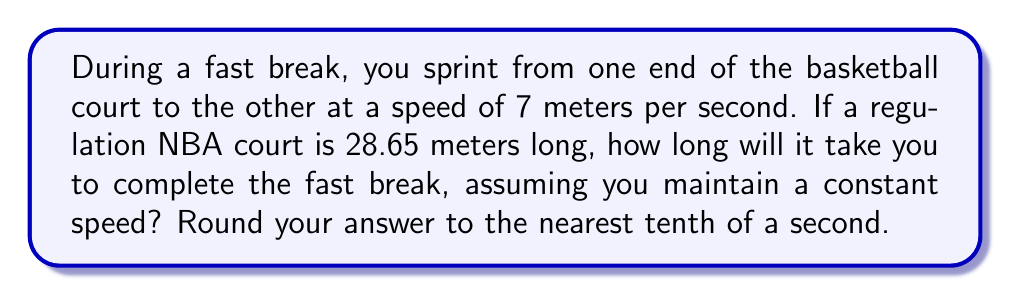Help me with this question. Let's approach this problem step-by-step using the rate equation:

1) The rate equation is: $\text{Distance} = \text{Rate} \times \text{Time}$

2) We can rearrange this to solve for time: $\text{Time} = \frac{\text{Distance}}{\text{Rate}}$

3) We're given:
   - Distance (length of court) = 28.65 meters
   - Rate (your speed) = 7 meters per second

4) Let's plug these values into our equation:

   $\text{Time} = \frac{28.65 \text{ m}}{7 \text{ m/s}}$

5) Now, let's calculate:

   $\text{Time} = 4.0928571429$ seconds

6) Rounding to the nearest tenth of a second:

   $\text{Time} \approx 4.1$ seconds
Answer: 4.1 seconds 